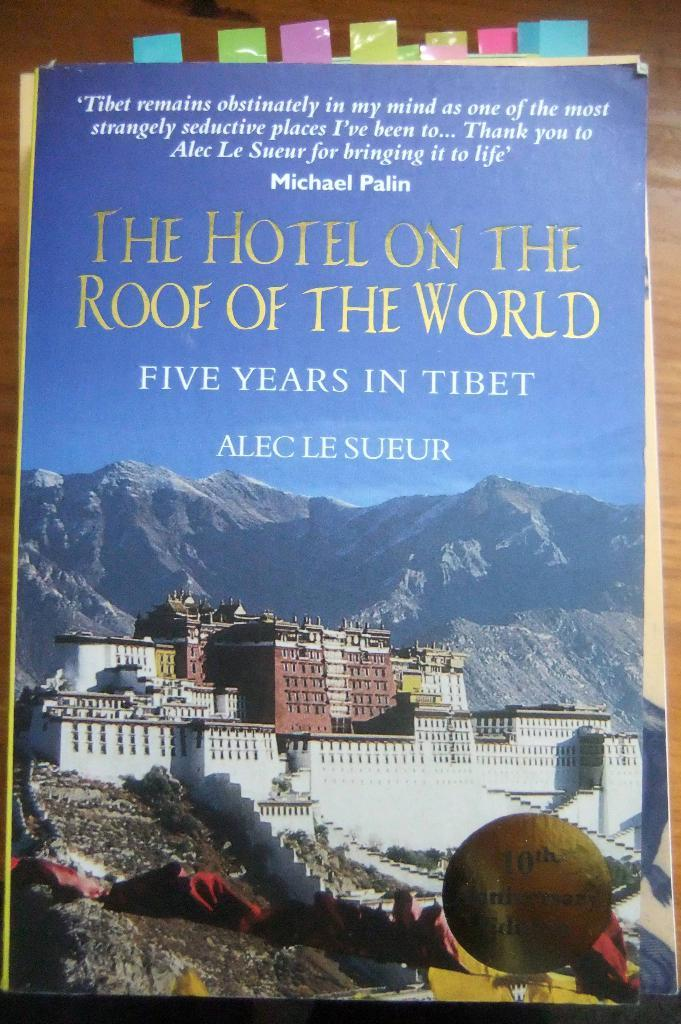<image>
Give a short and clear explanation of the subsequent image. The front cover of a book called, The Hotel on the Roof of the World. 